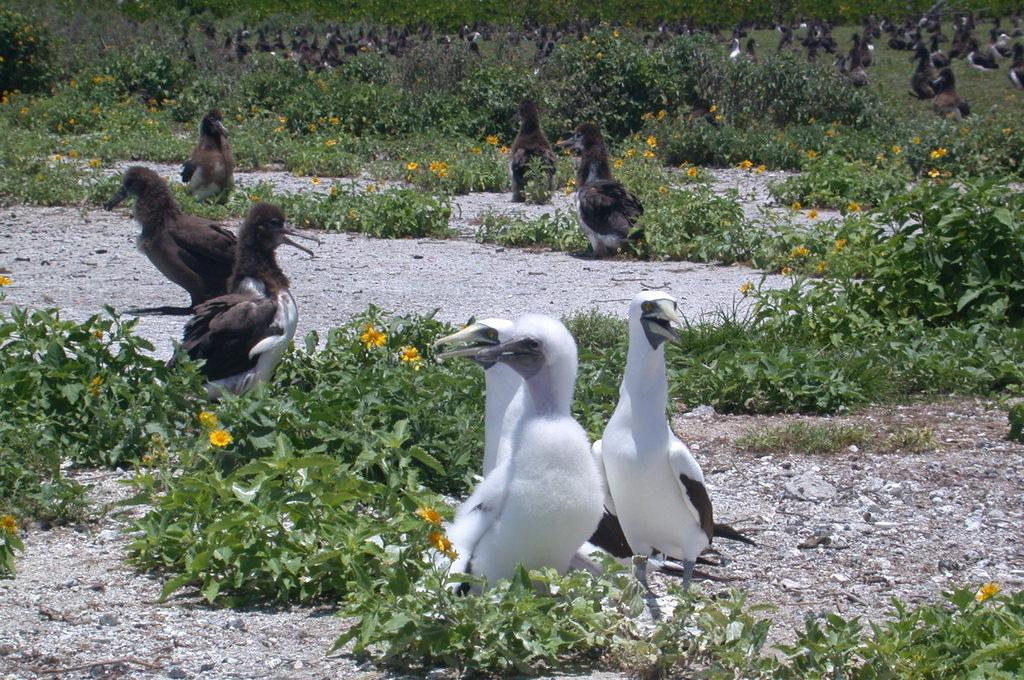What type of animals can be seen in the picture? There is a group of birds in the picture. What colors are the birds in the picture? The birds are white and black in color. What other elements can be seen in the picture besides the birds? There are plants with flowers in the picture. How many women are present in the picture? There are no women present in the picture; it features a group of birds and plants with flowers. What type of chin can be seen on the birds in the picture? Birds do not have chins, so this detail cannot be observed in the picture. 